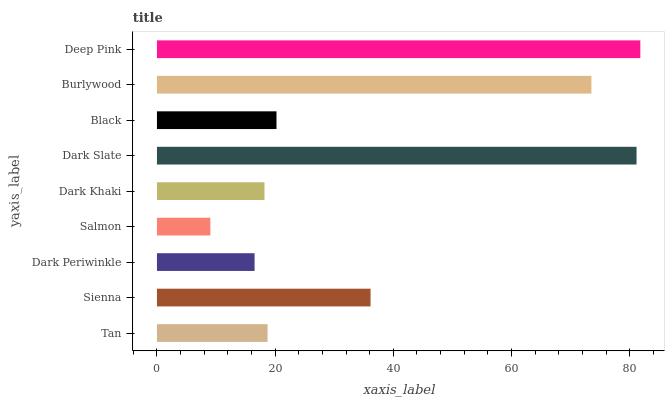Is Salmon the minimum?
Answer yes or no. Yes. Is Deep Pink the maximum?
Answer yes or no. Yes. Is Sienna the minimum?
Answer yes or no. No. Is Sienna the maximum?
Answer yes or no. No. Is Sienna greater than Tan?
Answer yes or no. Yes. Is Tan less than Sienna?
Answer yes or no. Yes. Is Tan greater than Sienna?
Answer yes or no. No. Is Sienna less than Tan?
Answer yes or no. No. Is Black the high median?
Answer yes or no. Yes. Is Black the low median?
Answer yes or no. Yes. Is Salmon the high median?
Answer yes or no. No. Is Dark Slate the low median?
Answer yes or no. No. 